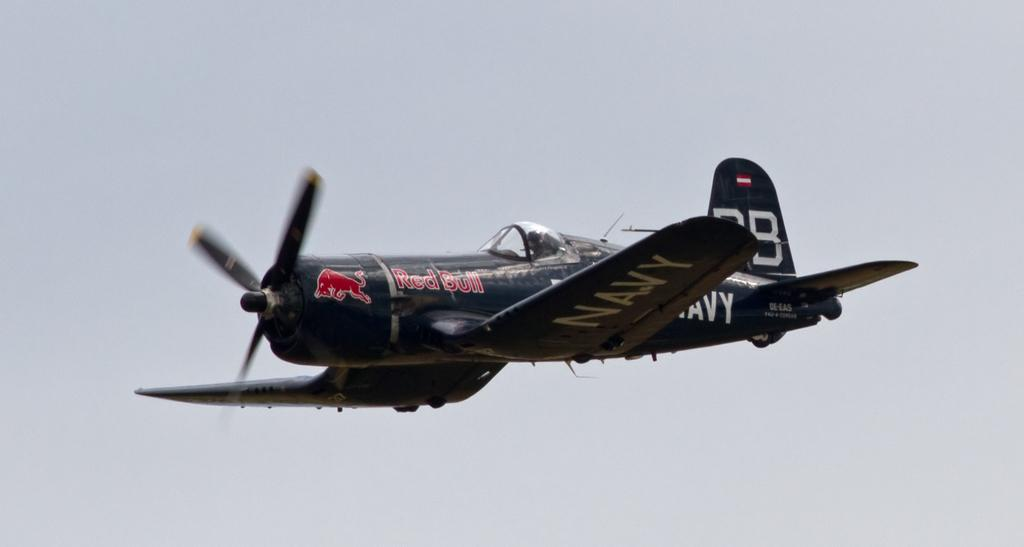What is the main subject of the picture? The main subject of the picture is an aircraft. What is the aircraft doing in the image? The aircraft is flying. Can you describe the person inside the aircraft? There is a person sitting inside the aircraft. What can be seen on the aircraft? There is text on the aircraft. What is visible at the top of the image? The sky is visible at the top of the image. What type of development is taking place near the aircraft in the image? There is no indication of any development taking place near the aircraft in the image. How does the size of the aircraft compare to the size of the person inside it? The size of the aircraft and the person inside it cannot be accurately compared based on the image alone. 